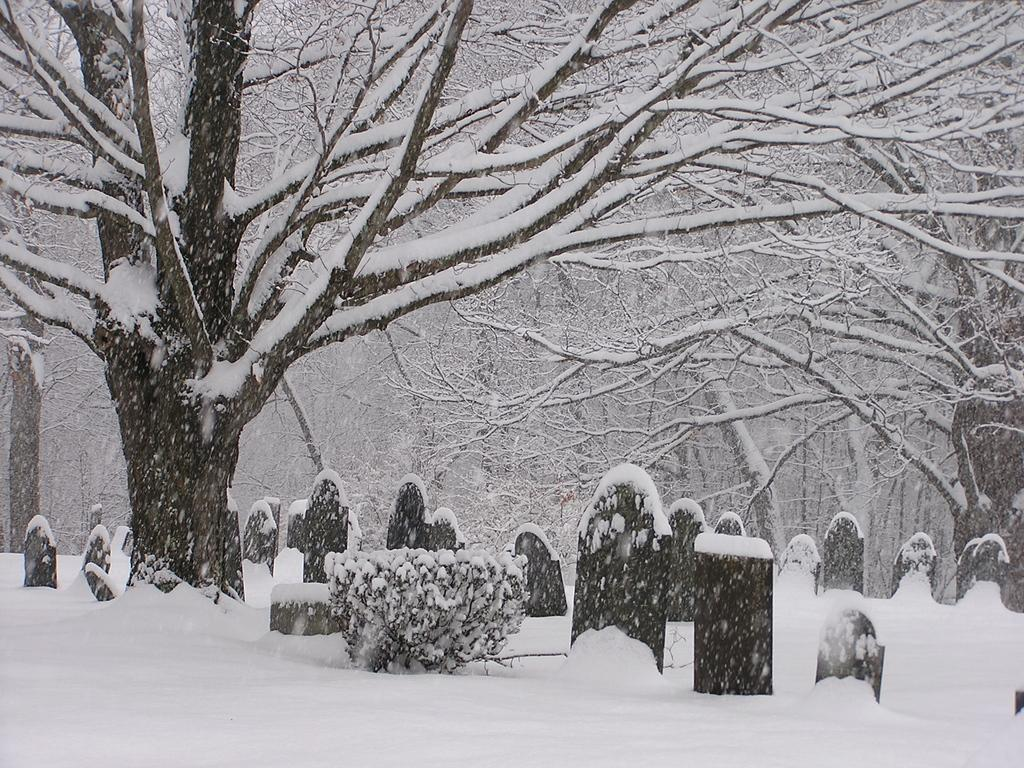What type of weather is depicted in the image? There is snow in the image, indicating a cold or wintry weather condition. What type of location is shown in the image? There are graveyards in the image, suggesting a cemetery or burial ground. What type of vegetation is present in the image? There are trees and a plant in the image. What type of quill can be seen in the image? There is no quill present in the image. How does the plate appear in the image? There is no plate present in the image. 